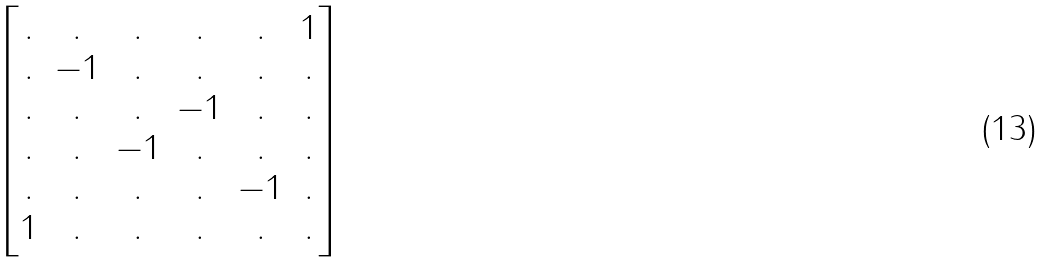<formula> <loc_0><loc_0><loc_500><loc_500>\begin{bmatrix} . & . & . & . & . & 1 \\ . & - 1 & . & . & . & . \\ . & . & . & - 1 & . & . \\ . & . & - 1 & . & . & . \\ . & . & . & . & - 1 & . \\ 1 & . & . & . & . & . \end{bmatrix}</formula> 